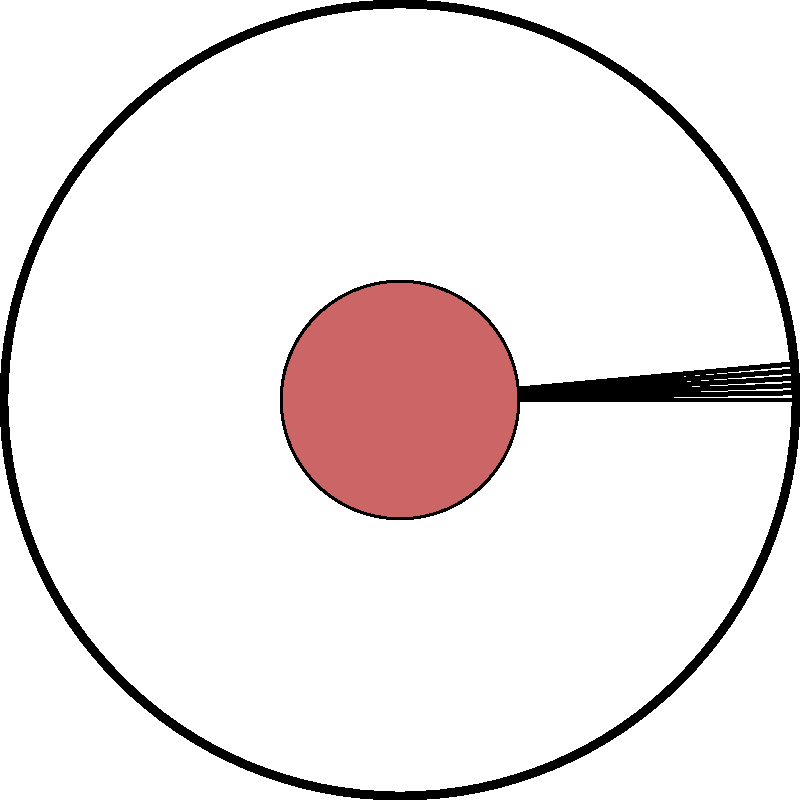In this simplified stained glass window design, a circular motif is divided into six equal segments. If each segment represents a scene from a religious text, and the design is repeated in a fractal pattern where each circular shape is replaced by a scaled-down version of the entire window, how many individual scenes would be depicted in the third iteration of this fractal pattern? To solve this problem, let's break it down step-by-step:

1) In the initial design (0th iteration), we have 6 scenes.

2) For the 1st iteration:
   - Each of the 6 original segments is replaced by a miniature version of the whole window.
   - Each miniature window contains 6 scenes.
   - So, the number of scenes in the 1st iteration is: $6 \times 6 = 36$

3) For the 2nd iteration:
   - Each of the 36 scenes from the 1st iteration is replaced by a miniature window.
   - So, the number of scenes in the 2nd iteration is: $36 \times 6 = 216$

4) For the 3rd iteration:
   - Each of the 216 scenes from the 2nd iteration is replaced by a miniature window.
   - So, the number of scenes in the 3rd iteration is: $216 \times 6 = 1,296$

5) We can express this mathematically as:
   Number of scenes in nth iteration = $6^{n+1}$
   For the 3rd iteration, $n = 3$, so: $6^{3+1} = 6^4 = 1,296$

Therefore, in the third iteration of this fractal pattern, there would be 1,296 individual scenes depicted.
Answer: 1,296 scenes 